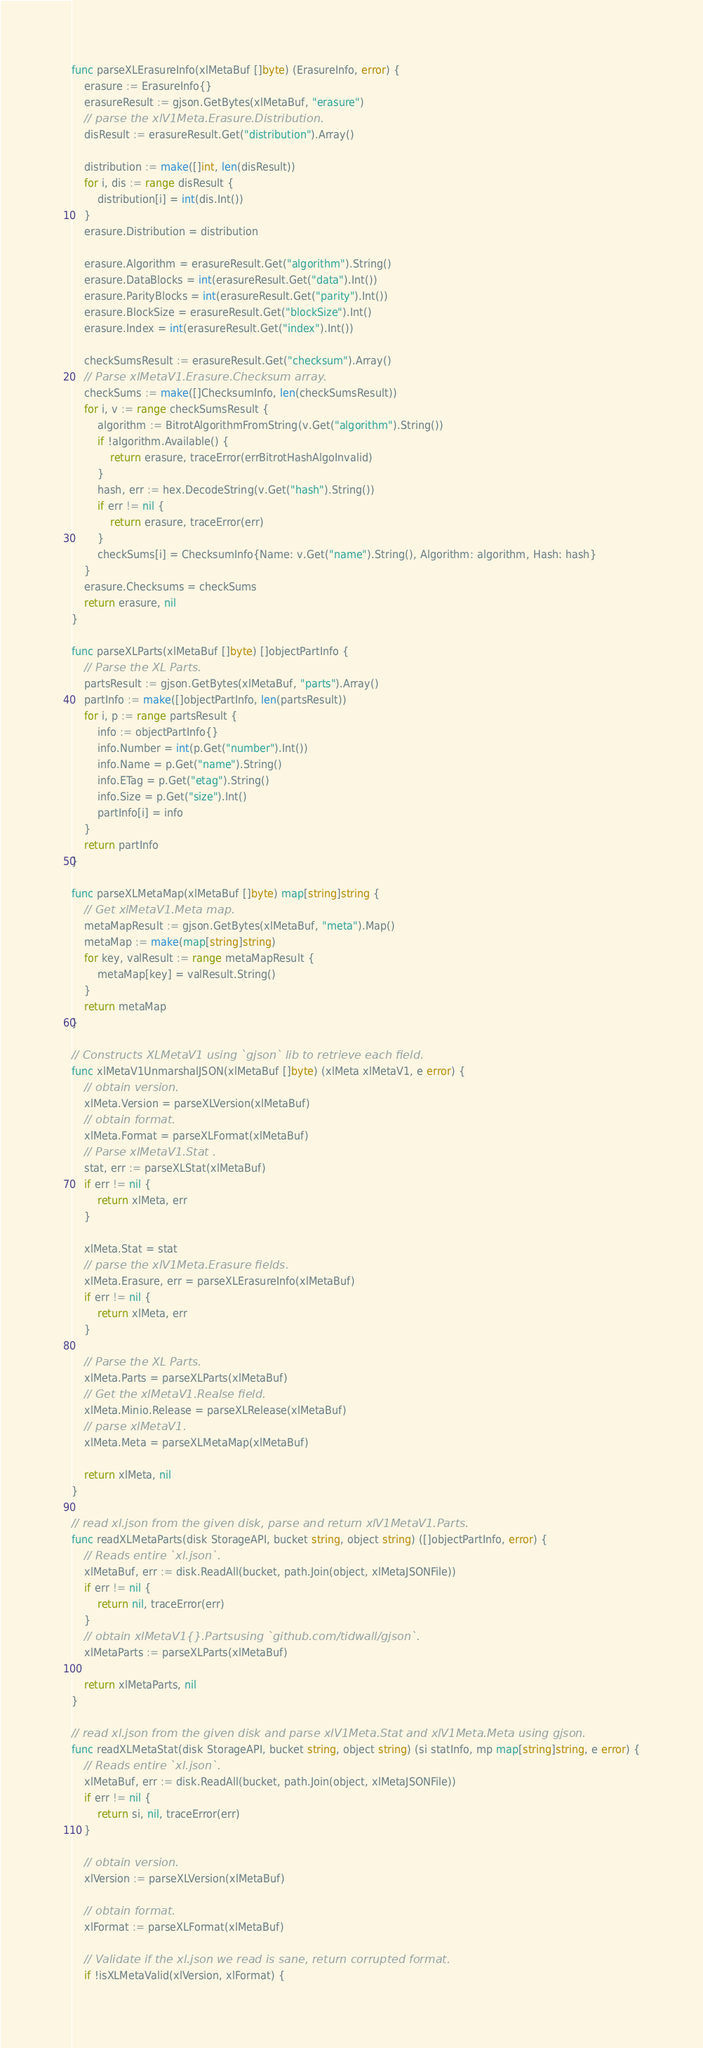Convert code to text. <code><loc_0><loc_0><loc_500><loc_500><_Go_>func parseXLErasureInfo(xlMetaBuf []byte) (ErasureInfo, error) {
	erasure := ErasureInfo{}
	erasureResult := gjson.GetBytes(xlMetaBuf, "erasure")
	// parse the xlV1Meta.Erasure.Distribution.
	disResult := erasureResult.Get("distribution").Array()

	distribution := make([]int, len(disResult))
	for i, dis := range disResult {
		distribution[i] = int(dis.Int())
	}
	erasure.Distribution = distribution

	erasure.Algorithm = erasureResult.Get("algorithm").String()
	erasure.DataBlocks = int(erasureResult.Get("data").Int())
	erasure.ParityBlocks = int(erasureResult.Get("parity").Int())
	erasure.BlockSize = erasureResult.Get("blockSize").Int()
	erasure.Index = int(erasureResult.Get("index").Int())

	checkSumsResult := erasureResult.Get("checksum").Array()
	// Parse xlMetaV1.Erasure.Checksum array.
	checkSums := make([]ChecksumInfo, len(checkSumsResult))
	for i, v := range checkSumsResult {
		algorithm := BitrotAlgorithmFromString(v.Get("algorithm").String())
		if !algorithm.Available() {
			return erasure, traceError(errBitrotHashAlgoInvalid)
		}
		hash, err := hex.DecodeString(v.Get("hash").String())
		if err != nil {
			return erasure, traceError(err)
		}
		checkSums[i] = ChecksumInfo{Name: v.Get("name").String(), Algorithm: algorithm, Hash: hash}
	}
	erasure.Checksums = checkSums
	return erasure, nil
}

func parseXLParts(xlMetaBuf []byte) []objectPartInfo {
	// Parse the XL Parts.
	partsResult := gjson.GetBytes(xlMetaBuf, "parts").Array()
	partInfo := make([]objectPartInfo, len(partsResult))
	for i, p := range partsResult {
		info := objectPartInfo{}
		info.Number = int(p.Get("number").Int())
		info.Name = p.Get("name").String()
		info.ETag = p.Get("etag").String()
		info.Size = p.Get("size").Int()
		partInfo[i] = info
	}
	return partInfo
}

func parseXLMetaMap(xlMetaBuf []byte) map[string]string {
	// Get xlMetaV1.Meta map.
	metaMapResult := gjson.GetBytes(xlMetaBuf, "meta").Map()
	metaMap := make(map[string]string)
	for key, valResult := range metaMapResult {
		metaMap[key] = valResult.String()
	}
	return metaMap
}

// Constructs XLMetaV1 using `gjson` lib to retrieve each field.
func xlMetaV1UnmarshalJSON(xlMetaBuf []byte) (xlMeta xlMetaV1, e error) {
	// obtain version.
	xlMeta.Version = parseXLVersion(xlMetaBuf)
	// obtain format.
	xlMeta.Format = parseXLFormat(xlMetaBuf)
	// Parse xlMetaV1.Stat .
	stat, err := parseXLStat(xlMetaBuf)
	if err != nil {
		return xlMeta, err
	}

	xlMeta.Stat = stat
	// parse the xlV1Meta.Erasure fields.
	xlMeta.Erasure, err = parseXLErasureInfo(xlMetaBuf)
	if err != nil {
		return xlMeta, err
	}

	// Parse the XL Parts.
	xlMeta.Parts = parseXLParts(xlMetaBuf)
	// Get the xlMetaV1.Realse field.
	xlMeta.Minio.Release = parseXLRelease(xlMetaBuf)
	// parse xlMetaV1.
	xlMeta.Meta = parseXLMetaMap(xlMetaBuf)

	return xlMeta, nil
}

// read xl.json from the given disk, parse and return xlV1MetaV1.Parts.
func readXLMetaParts(disk StorageAPI, bucket string, object string) ([]objectPartInfo, error) {
	// Reads entire `xl.json`.
	xlMetaBuf, err := disk.ReadAll(bucket, path.Join(object, xlMetaJSONFile))
	if err != nil {
		return nil, traceError(err)
	}
	// obtain xlMetaV1{}.Partsusing `github.com/tidwall/gjson`.
	xlMetaParts := parseXLParts(xlMetaBuf)

	return xlMetaParts, nil
}

// read xl.json from the given disk and parse xlV1Meta.Stat and xlV1Meta.Meta using gjson.
func readXLMetaStat(disk StorageAPI, bucket string, object string) (si statInfo, mp map[string]string, e error) {
	// Reads entire `xl.json`.
	xlMetaBuf, err := disk.ReadAll(bucket, path.Join(object, xlMetaJSONFile))
	if err != nil {
		return si, nil, traceError(err)
	}

	// obtain version.
	xlVersion := parseXLVersion(xlMetaBuf)

	// obtain format.
	xlFormat := parseXLFormat(xlMetaBuf)

	// Validate if the xl.json we read is sane, return corrupted format.
	if !isXLMetaValid(xlVersion, xlFormat) {</code> 